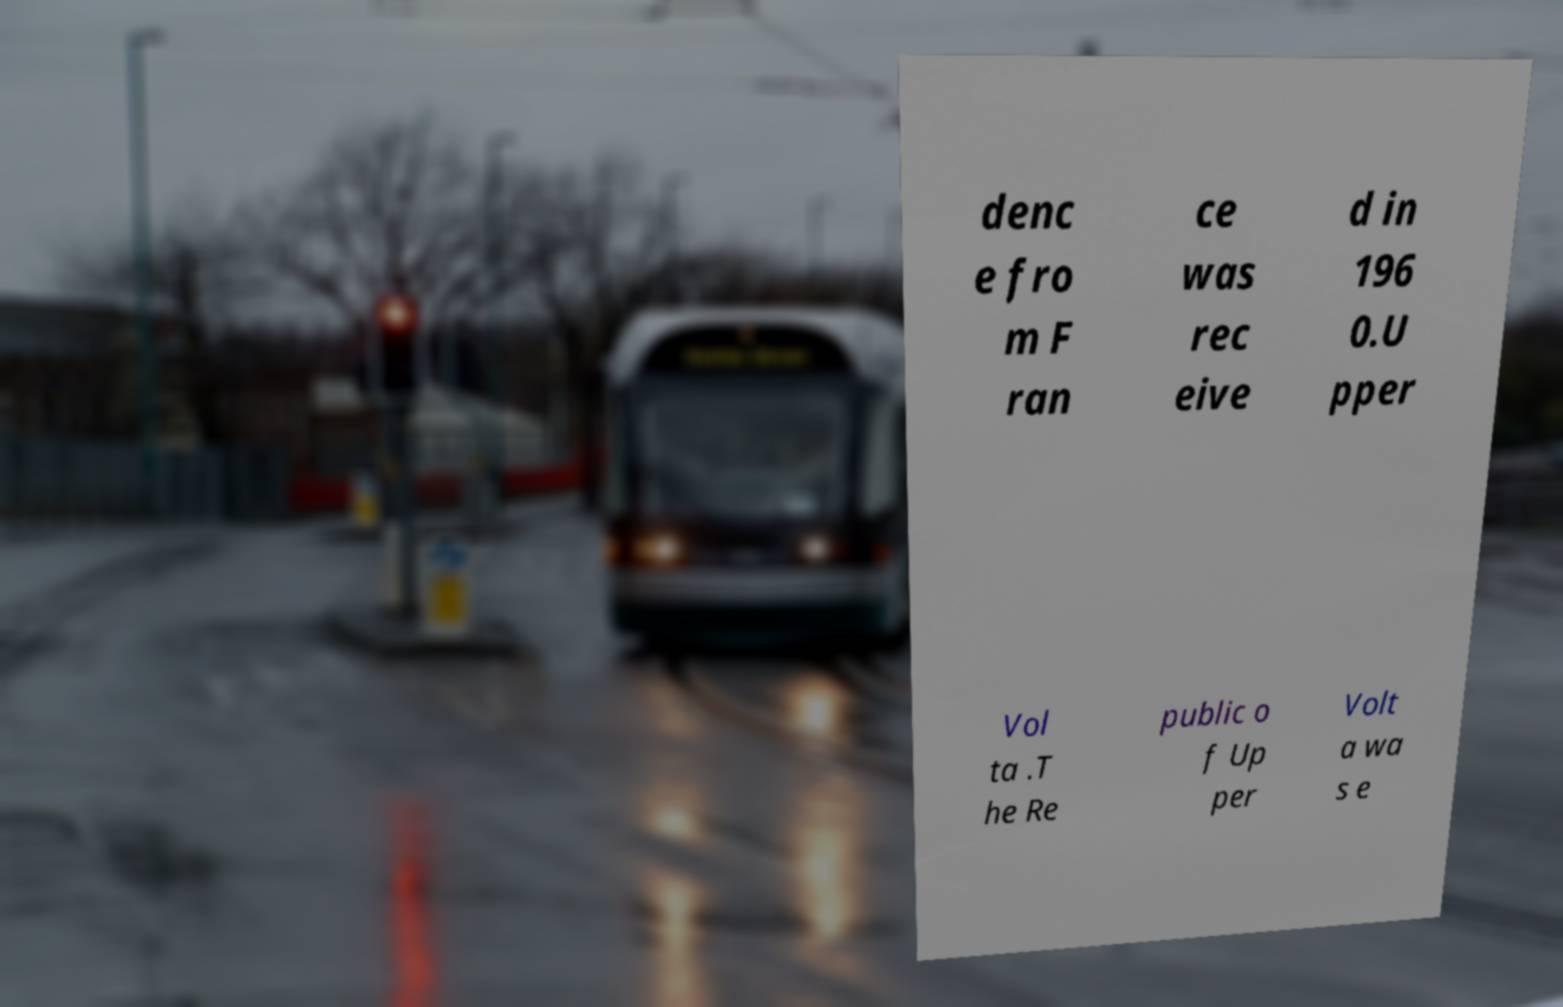Could you extract and type out the text from this image? denc e fro m F ran ce was rec eive d in 196 0.U pper Vol ta .T he Re public o f Up per Volt a wa s e 